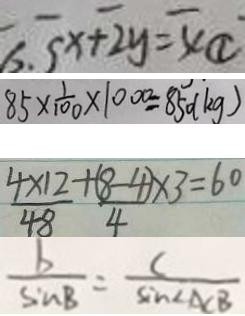Convert formula to latex. <formula><loc_0><loc_0><loc_500><loc_500>x + 2 y = 4 \textcircled { 1 } 
 8 5 \times \frac { 1 } { 1 0 0 } \times 1 0 0 0 = 8 5 0 ( k g ) 
 \frac { 4 \times 1 2 } { 4 8 } + \frac { ( 8 - 4 ) \times 3 } { 4 } \times 3 = 6 0 
 \frac { b } { \sin B } = \frac { C } { \sin \angle A C B }</formula> 